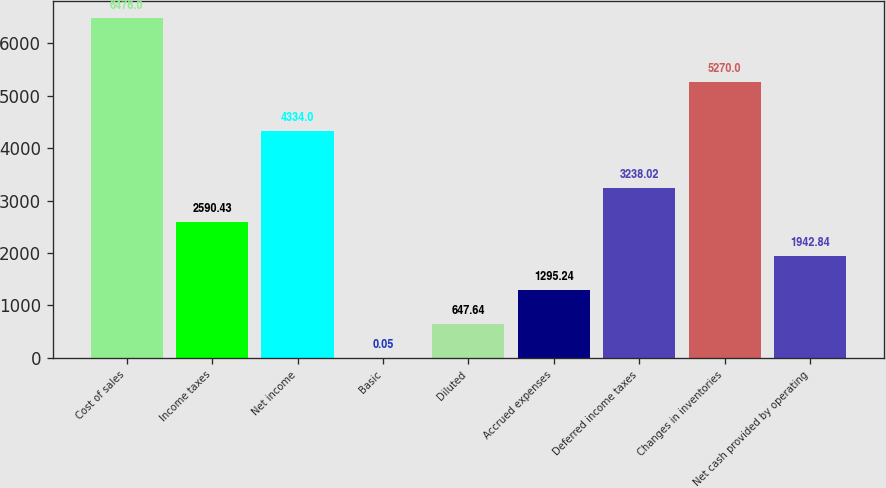Convert chart. <chart><loc_0><loc_0><loc_500><loc_500><bar_chart><fcel>Cost of sales<fcel>Income taxes<fcel>Net income<fcel>Basic<fcel>Diluted<fcel>Accrued expenses<fcel>Deferred income taxes<fcel>Changes in inventories<fcel>Net cash provided by operating<nl><fcel>6476<fcel>2590.43<fcel>4334<fcel>0.05<fcel>647.64<fcel>1295.24<fcel>3238.02<fcel>5270<fcel>1942.84<nl></chart> 